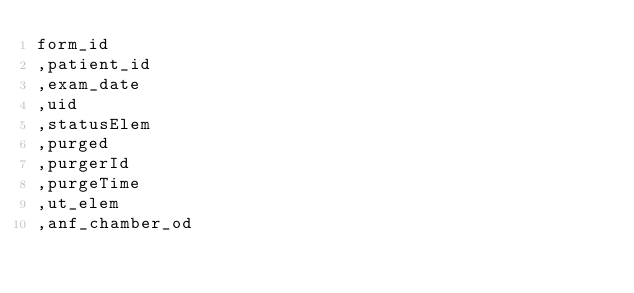<code> <loc_0><loc_0><loc_500><loc_500><_SQL_>form_id
,patient_id
,exam_date
,uid
,statusElem
,purged
,purgerId
,purgeTime
,ut_elem
,anf_chamber_od</code> 